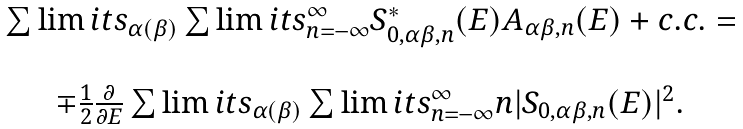Convert formula to latex. <formula><loc_0><loc_0><loc_500><loc_500>\begin{array} { c } \sum \lim i t s _ { \alpha ( \beta ) } \sum \lim i t s _ { n = - \infty } ^ { \infty } S ^ { * } _ { 0 , \alpha \beta , n } ( E ) A _ { \alpha \beta , n } ( E ) + c . c . = \\ \ \\ \mp \frac { 1 } { 2 } \frac { \partial } { \partial E } \sum \lim i t s _ { \alpha ( \beta ) } \sum \lim i t s _ { n = - \infty } ^ { \infty } n | S _ { 0 , \alpha \beta , n } ( E ) | ^ { 2 } . \end{array}</formula> 